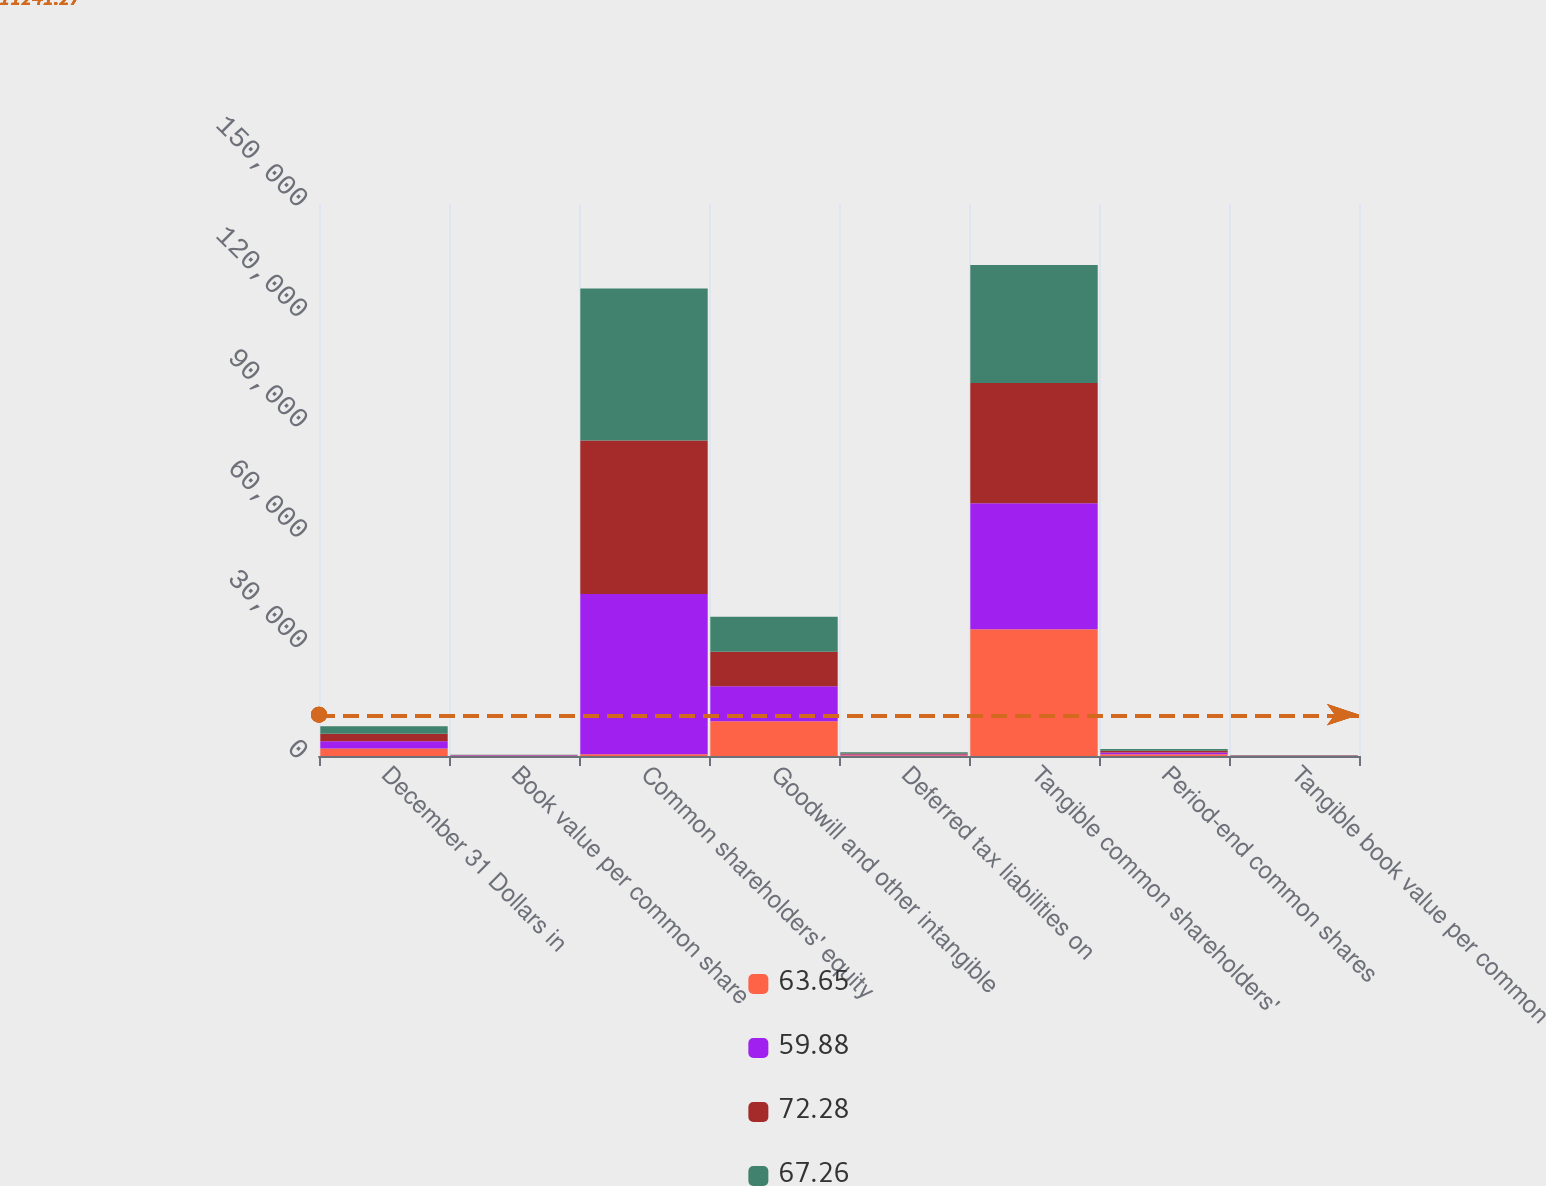Convert chart. <chart><loc_0><loc_0><loc_500><loc_500><stacked_bar_chart><ecel><fcel>December 31 Dollars in<fcel>Book value per common share<fcel>Common shareholders' equity<fcel>Goodwill and other intangible<fcel>Deferred tax liabilities on<fcel>Tangible common shareholders'<fcel>Period-end common shares<fcel>Tangible book value per common<nl><fcel>63.65<fcel>2018<fcel>95.72<fcel>504<fcel>9467<fcel>190<fcel>34465<fcel>457<fcel>75.42<nl><fcel>59.88<fcel>2017<fcel>91.94<fcel>43530<fcel>9498<fcel>191<fcel>34223<fcel>473<fcel>72.28<nl><fcel>72.28<fcel>2016<fcel>85.94<fcel>41723<fcel>9376<fcel>304<fcel>32651<fcel>485<fcel>67.26<nl><fcel>67.26<fcel>2015<fcel>81.84<fcel>41258<fcel>9482<fcel>310<fcel>32086<fcel>504<fcel>63.65<nl></chart> 